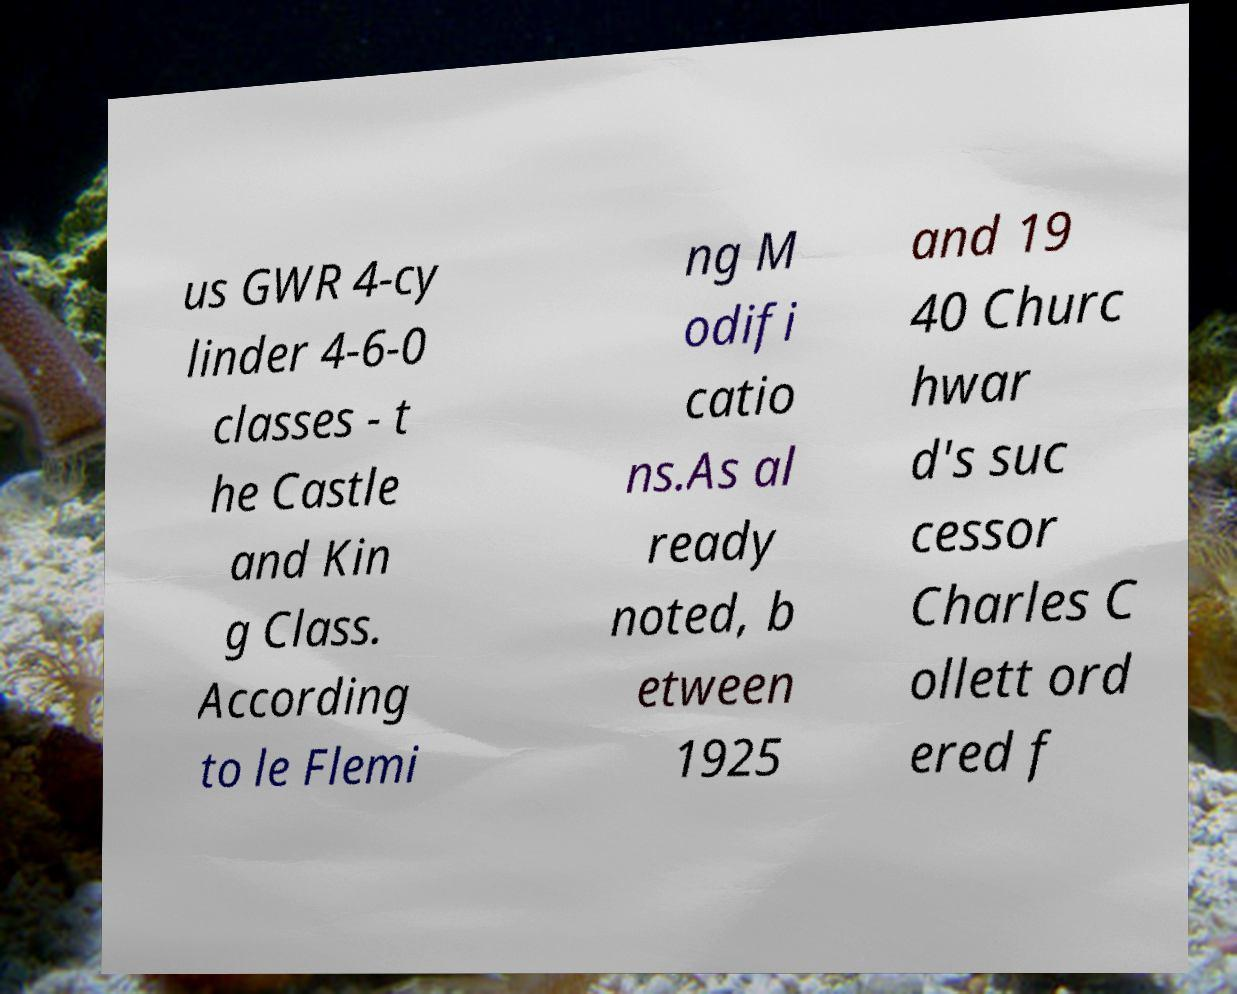For documentation purposes, I need the text within this image transcribed. Could you provide that? us GWR 4-cy linder 4-6-0 classes - t he Castle and Kin g Class. According to le Flemi ng M odifi catio ns.As al ready noted, b etween 1925 and 19 40 Churc hwar d's suc cessor Charles C ollett ord ered f 